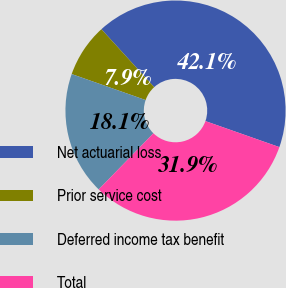<chart> <loc_0><loc_0><loc_500><loc_500><pie_chart><fcel>Net actuarial loss<fcel>Prior service cost<fcel>Deferred income tax benefit<fcel>Total<nl><fcel>42.14%<fcel>7.86%<fcel>18.09%<fcel>31.91%<nl></chart> 